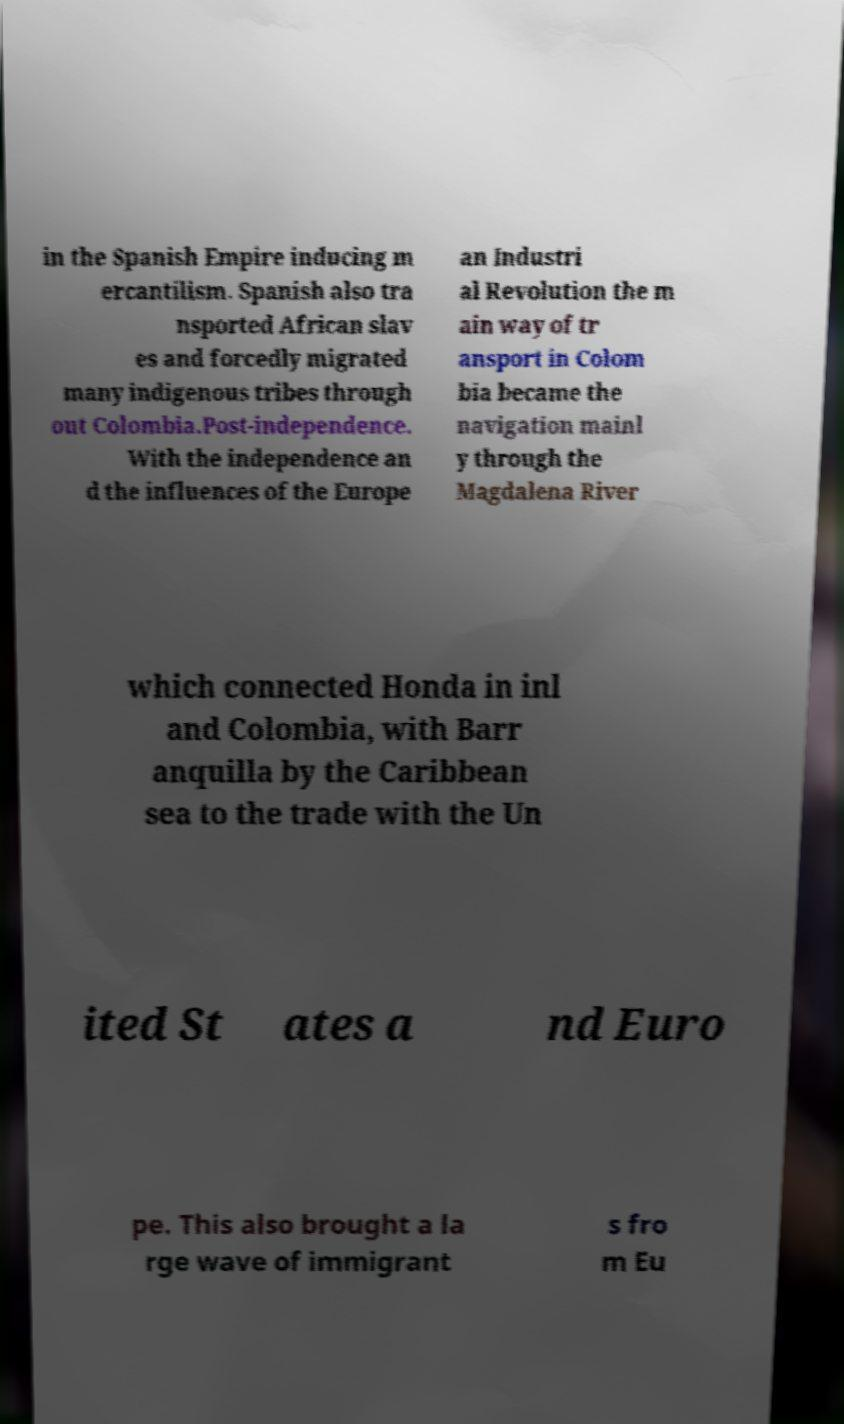Can you accurately transcribe the text from the provided image for me? in the Spanish Empire inducing m ercantilism. Spanish also tra nsported African slav es and forcedly migrated many indigenous tribes through out Colombia.Post-independence. With the independence an d the influences of the Europe an Industri al Revolution the m ain way of tr ansport in Colom bia became the navigation mainl y through the Magdalena River which connected Honda in inl and Colombia, with Barr anquilla by the Caribbean sea to the trade with the Un ited St ates a nd Euro pe. This also brought a la rge wave of immigrant s fro m Eu 